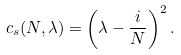Convert formula to latex. <formula><loc_0><loc_0><loc_500><loc_500>c _ { s } ( N , \lambda ) = \left ( \lambda - \frac { i } { N } \right ) ^ { 2 } .</formula> 